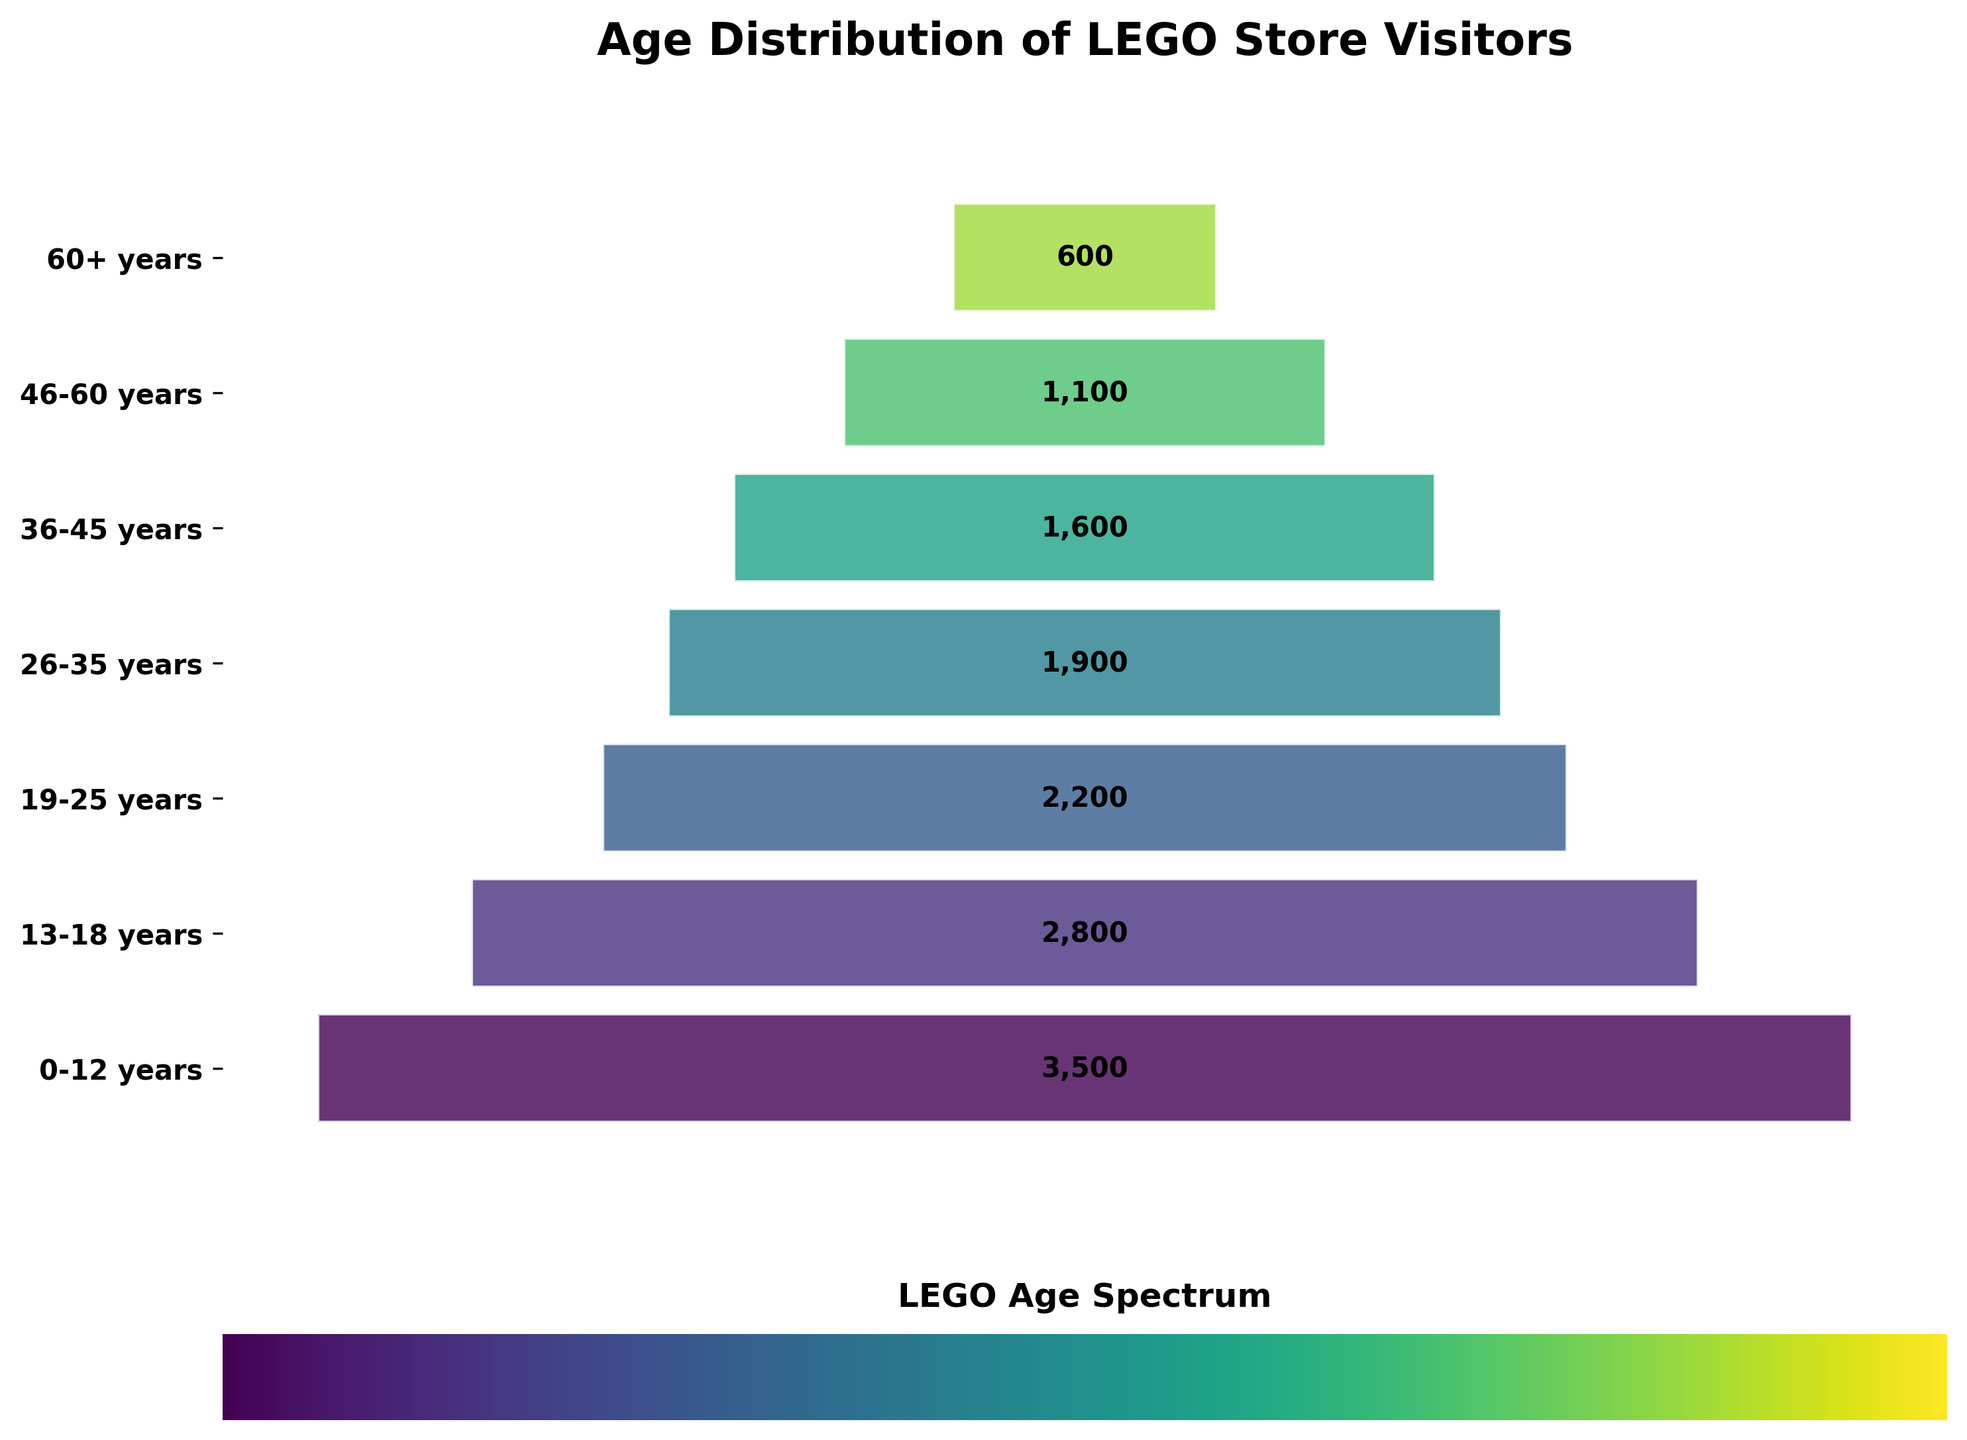How many age groups are in the chart? There are labels on the vertical axis that represent different age groups. By counting these labels, we see there are seven age groups.
Answer: Seven What is the age group with the most visitors? Looking at the funnel chart, the age group with the widest segment (top segment) has the most visitors. This is the "0-12 years" age group.
Answer: 0-12 years What age group has the fewest visitors? By identifying the narrowest funnel segment (bottom segment) on the chart, we see that the age group "60+ years" has the fewest visitors.
Answer: 60+ years What is the total number of visitors across all age groups? To find the total, we sum the visitors of all age groups: 3500 + 2800 + 2200 + 1900 + 1600 + 1100 + 600. This totals 13,700 visitors.
Answer: 13,700 What is the difference in the number of visitors between the "0-12 years" age group and the "60+ years" age group? First, find the number of visitors in each group: 3500 (0-12 years) and 600 (60+ years). Subtract the smaller from the larger: 3500 - 600 = 2900.
Answer: 2,900 How many visitors fall into the 19-35 years age range? Sum the visitors from the "19-25 years" and "26-35 years" groups. This calculation is 2200 + 1900 = 4100.
Answer: 4,100 Which age group between "36-45 years" and "46-60 years" has more visitors? Compare the visitor counts for the "36-45 years" group (1600) and the "46-60 years" group (1100). "36-45 years" has more visitors.
Answer: 36-45 years Estimate the proportion of total visitors that are in the 13-25 years age range. Sum the visitors in the 13-18 years and 19-25 years groups: 2800 + 2200 = 5000. Calculate the proportion: 5000 / 13700 ≈ 0.364 or 36.4%.
Answer: 36.4% How many more visitors are there in the "0-12 years" group compared to the "26-35 years" group? Subtract the visitors in the "26-35 years" group (1900) from the visitors in the "0-12 years" group (3500): 3500 - 1900 = 1600.
Answer: 1,600 Which age group represents the mid-point in the number of visitors? First, sort the visitors data: 600, 1100, 1600, 1900, 2200, 2800, 3500. The mid-point (4th value) is the "26-35 years" group with 1900 visitors.
Answer: 26-35 years 